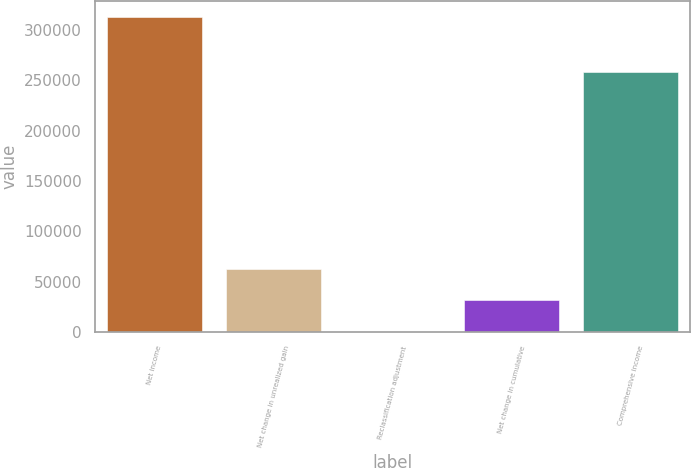<chart> <loc_0><loc_0><loc_500><loc_500><bar_chart><fcel>Net income<fcel>Net change in unrealized gain<fcel>Reclassification adjustment<fcel>Net change in cumulative<fcel>Comprehensive income<nl><fcel>312723<fcel>62601.4<fcel>71<fcel>31336.2<fcel>257863<nl></chart> 